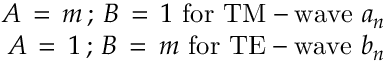<formula> <loc_0><loc_0><loc_500><loc_500>\begin{array} { r } { A \, = \, m \, ; \, B \, = \, 1 \, f o r \, T M - w a v e \, a _ { n } } \\ { \ A \, = \, 1 \, ; \, B \, = \, m \, f o r \, T E - w a v e \, b _ { n } } \end{array}</formula> 